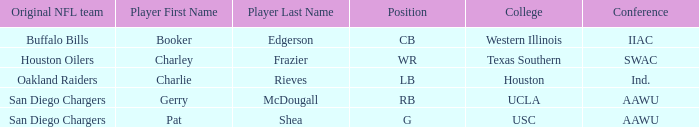What player's original team are the Buffalo Bills? Booker Edgerson Category:Articles with hCards †. 